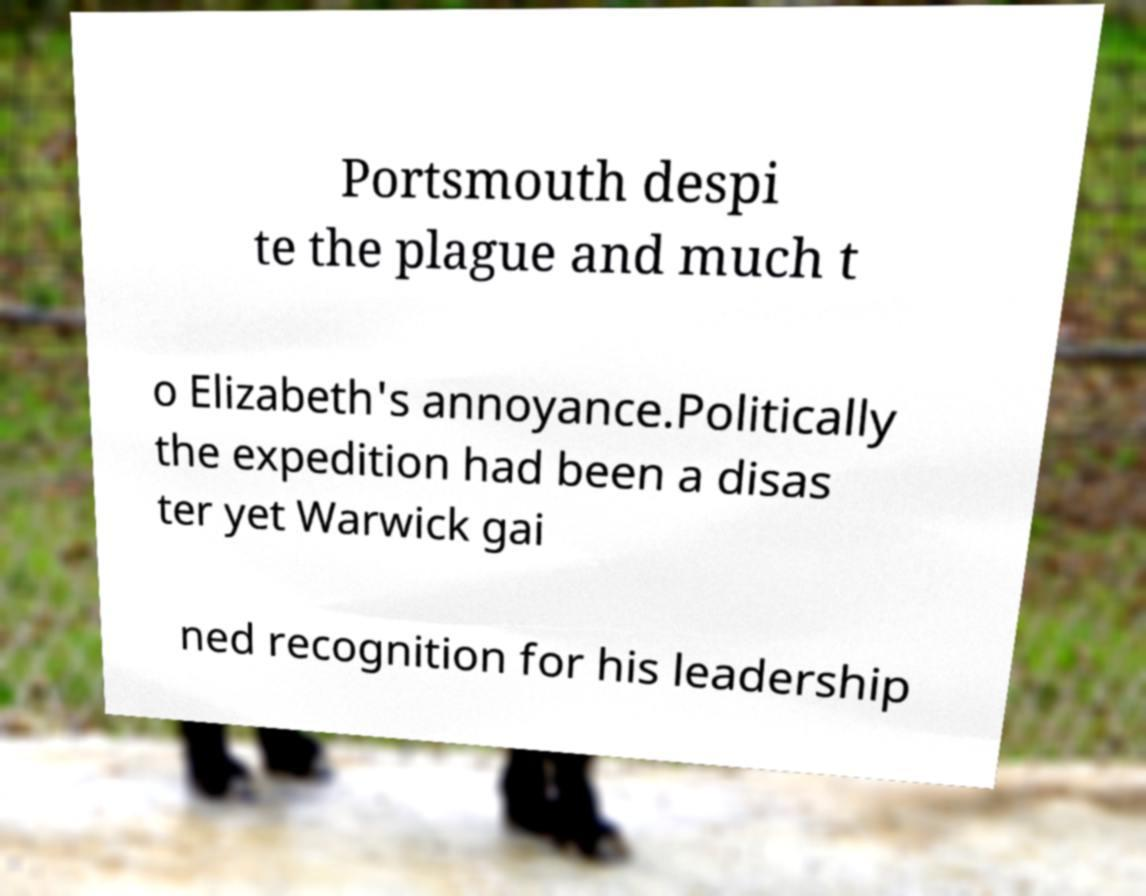There's text embedded in this image that I need extracted. Can you transcribe it verbatim? Portsmouth despi te the plague and much t o Elizabeth's annoyance.Politically the expedition had been a disas ter yet Warwick gai ned recognition for his leadership 